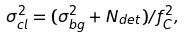<formula> <loc_0><loc_0><loc_500><loc_500>\sigma ^ { 2 } _ { c l } = ( \sigma ^ { 2 } _ { b g } + N _ { d e t } ) / f _ { C } ^ { 2 } ,</formula> 